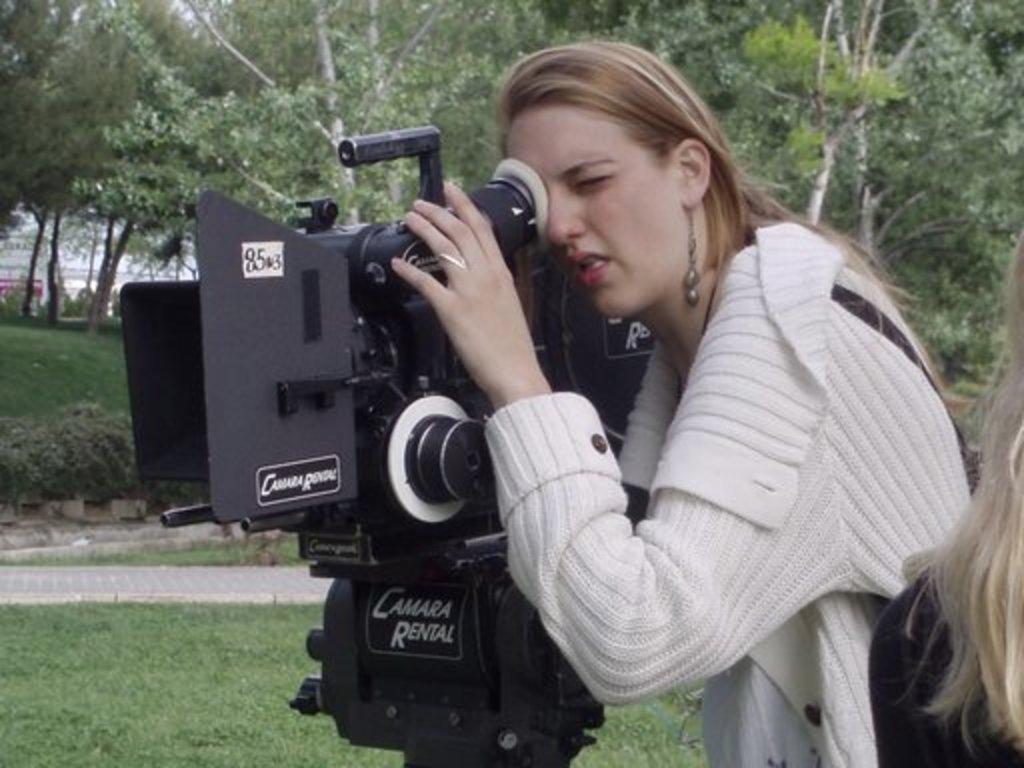Please provide a concise description of this image. a person is standing wearing a white dress watching into a camera. which is on the grass. behind them there are trees. 